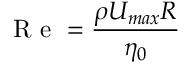<formula> <loc_0><loc_0><loc_500><loc_500>R e = \frac { \rho U _ { \max } R } { \eta _ { 0 } }</formula> 